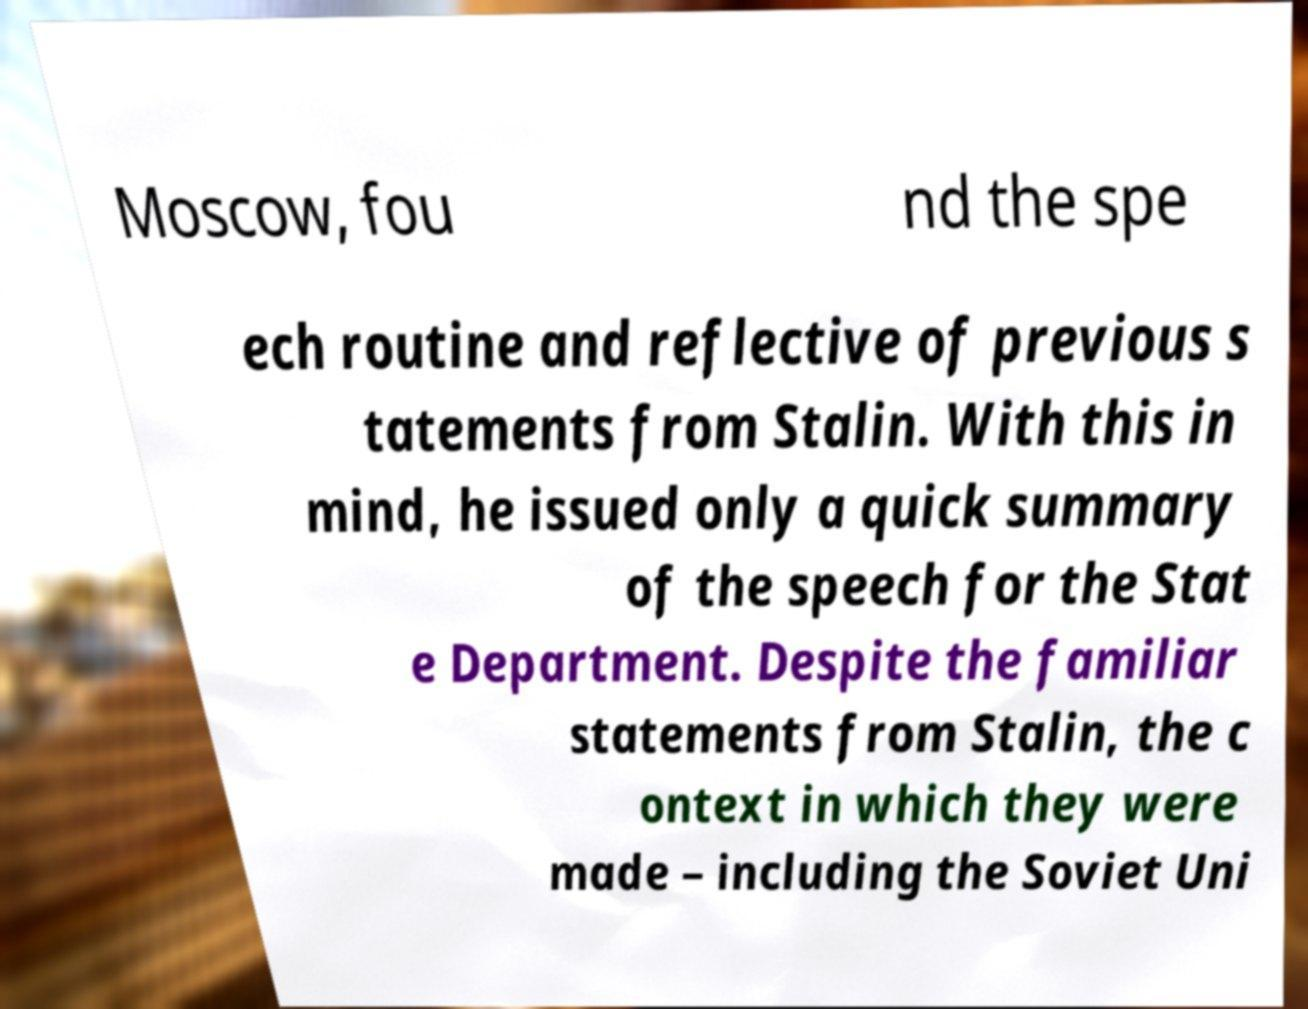I need the written content from this picture converted into text. Can you do that? Moscow, fou nd the spe ech routine and reflective of previous s tatements from Stalin. With this in mind, he issued only a quick summary of the speech for the Stat e Department. Despite the familiar statements from Stalin, the c ontext in which they were made – including the Soviet Uni 